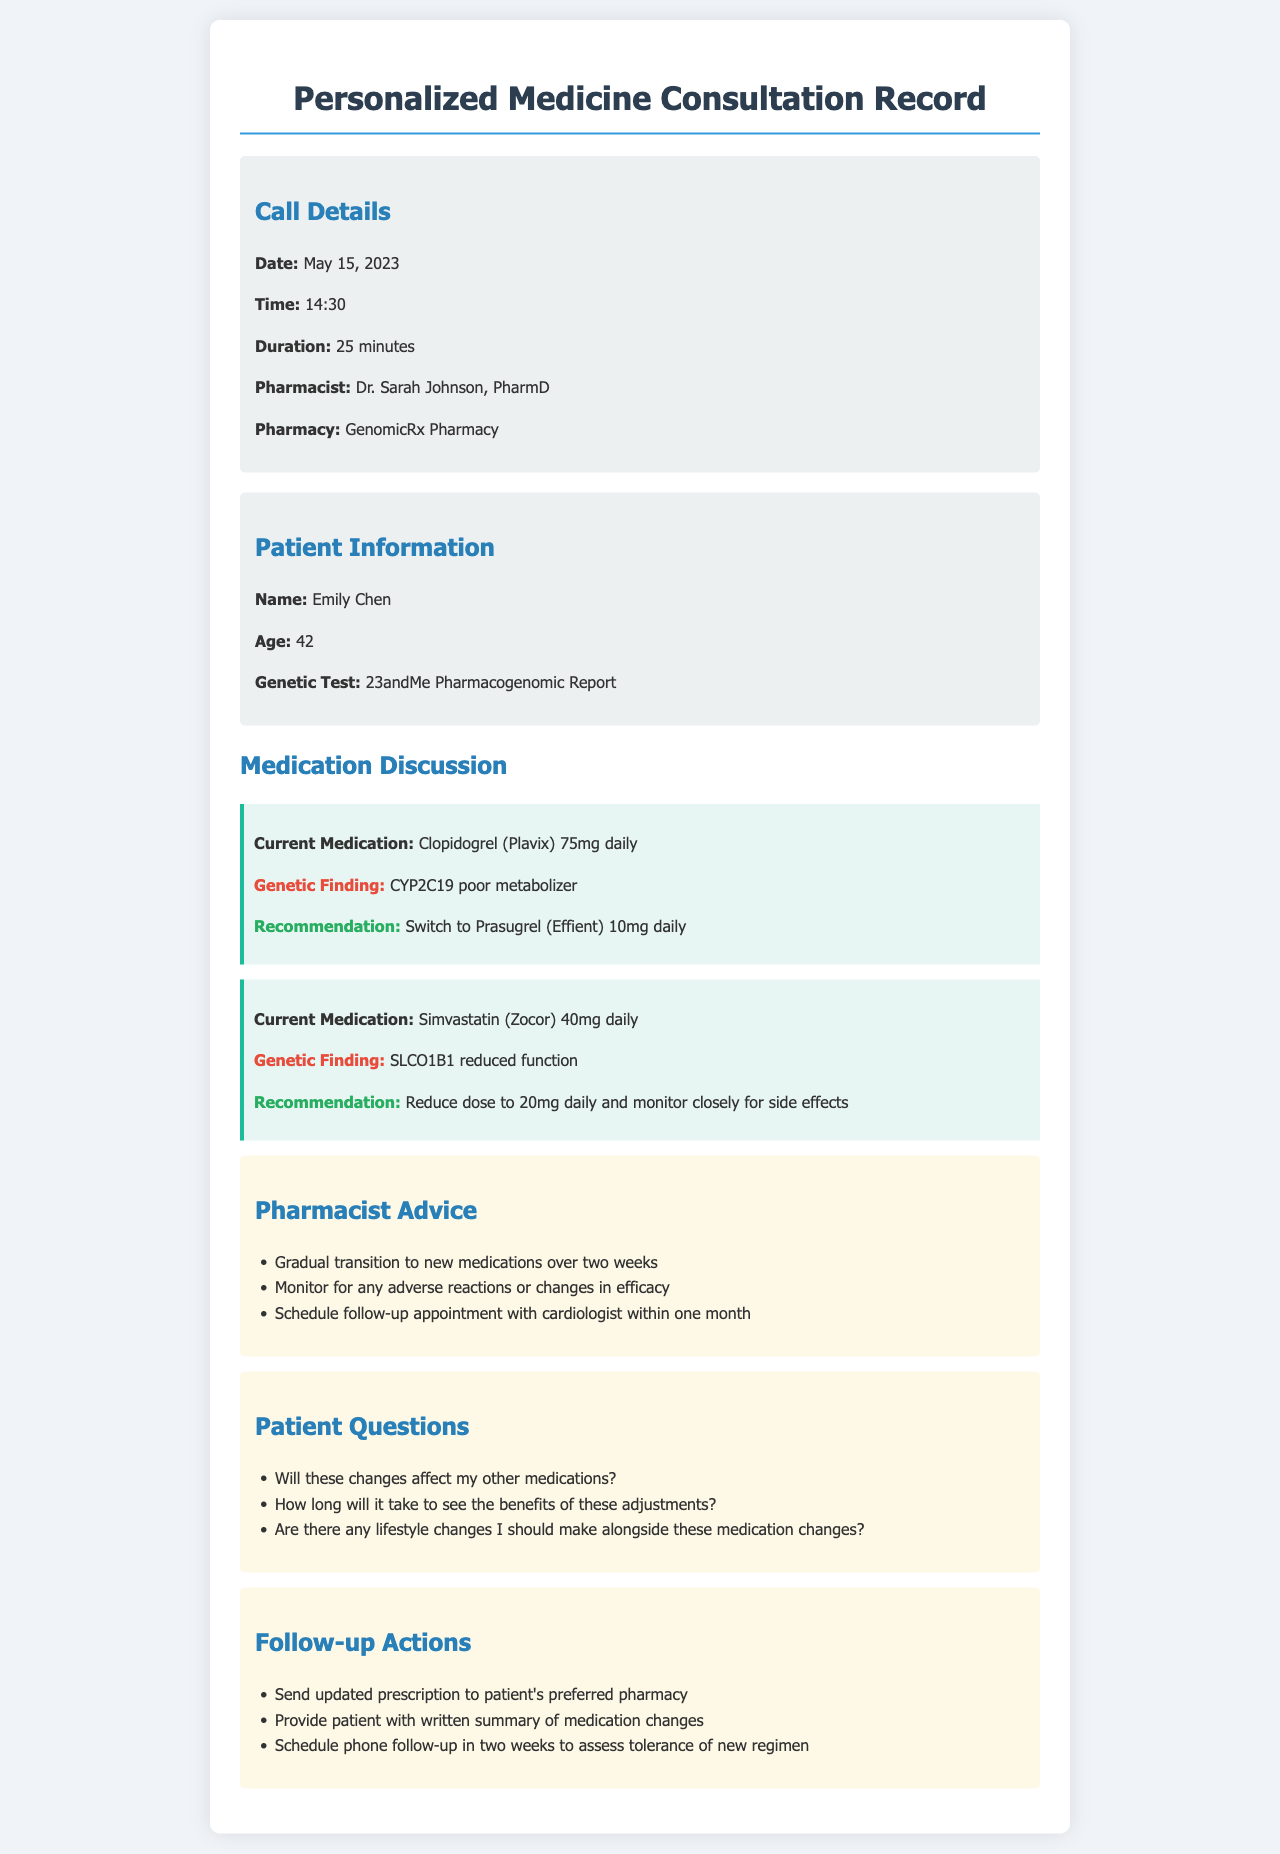What is the date of the consultation? The consultation date is specifically noted in the call details section of the document.
Answer: May 15, 2023 Who is the pharmacist conducting the consultation? The document identifies the pharmacist responsible for the consultation in the call details section.
Answer: Dr. Sarah Johnson What is the genetic finding related to Clopidogrel? The genetic finding for Clopidogrel is described in the medication discussion section of the document.
Answer: CYP2C19 poor metabolizer What is the recommended dosage for Prasugrel? The recommendation for Prasugrel dosage is clearly stated under the medication discussion section.
Answer: 10mg daily How long is the gradual transition to new medications suggested to take? This duration is specified in the advice given by the pharmacist in the document.
Answer: Two weeks What follow-up action is suggested after two weeks? The follow-up action to assess medication tolerance is listed in the follow-up actions section of the document.
Answer: Schedule phone follow-up What lifestyle changes should be considered with medication adjustments? The document suggests that the patient inquired about lifestyle considerations alongside medication changes.
Answer: None specified (the answer reflects the absence of direct information) How many minutes did the consultation last? The consultation duration is detailed in the call details section of the document.
Answer: 25 minutes 